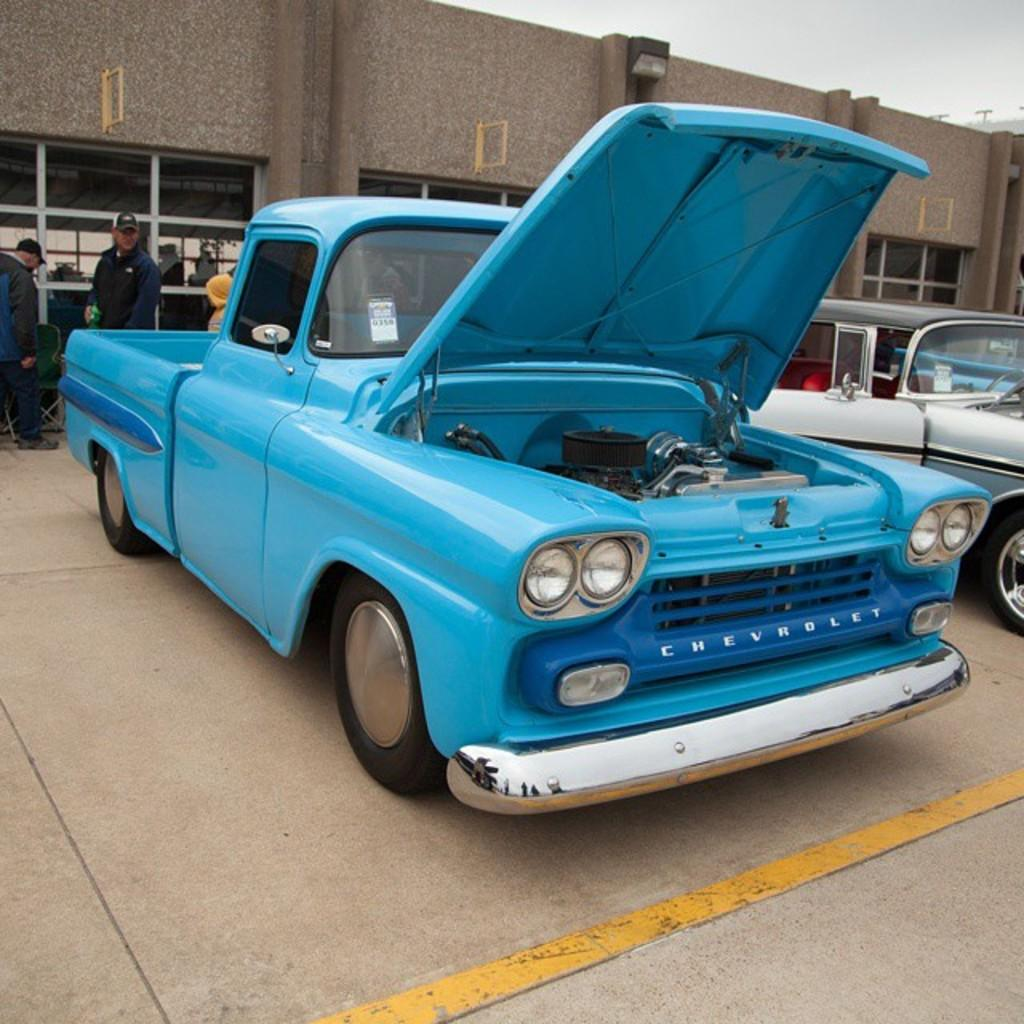What can be seen on the road in the image? There are vehicles on the road in the image. Can you describe the vehicle on the left side? The vehicle on the left side is blue in color. What else can be seen in the background of the image? There are people, a building, the sky, and other objects present in the background of the image. How does the rice affect the movement of the vehicles in the image? There is no rice present in the image, so it cannot affect the movement of the vehicles. 